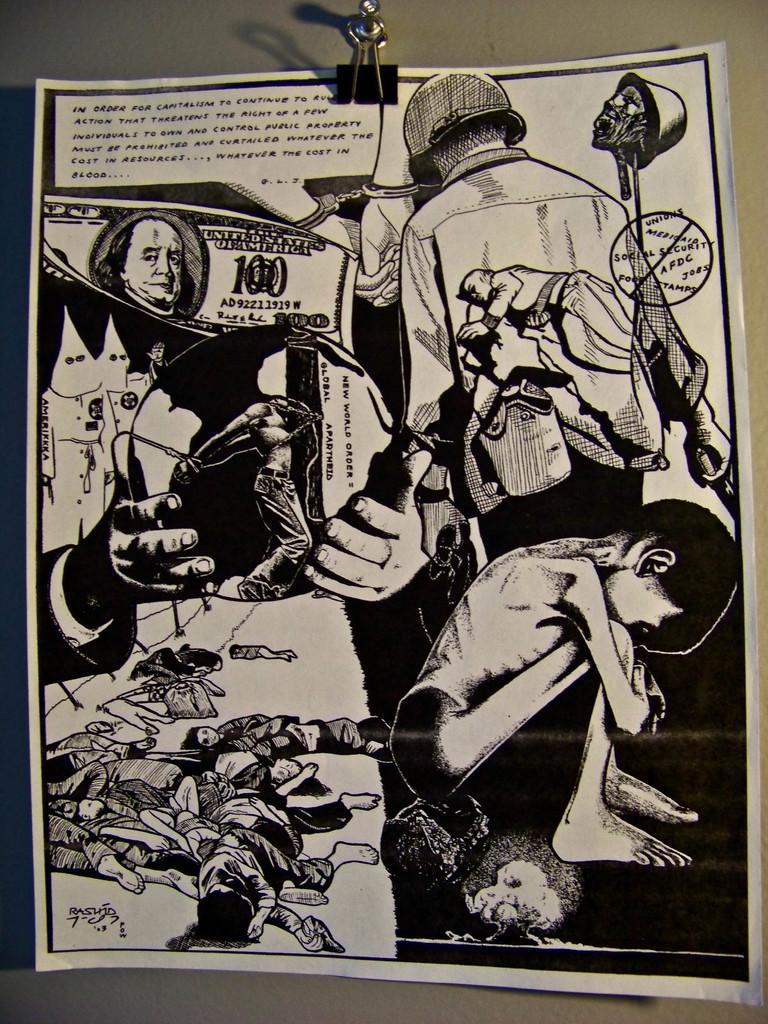How many dollars is the pictured bill worth?
Offer a terse response. 100. 